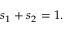<formula> <loc_0><loc_0><loc_500><loc_500>\begin{array} { r } { s _ { 1 } + s _ { 2 } = 1 . } \end{array}</formula> 